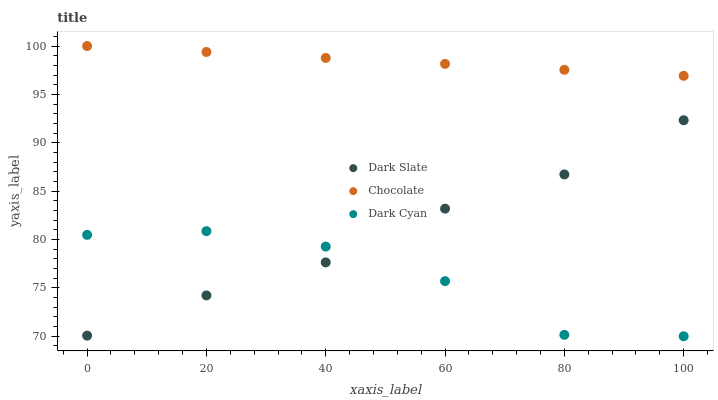Does Dark Cyan have the minimum area under the curve?
Answer yes or no. Yes. Does Chocolate have the maximum area under the curve?
Answer yes or no. Yes. Does Dark Slate have the minimum area under the curve?
Answer yes or no. No. Does Dark Slate have the maximum area under the curve?
Answer yes or no. No. Is Chocolate the smoothest?
Answer yes or no. Yes. Is Dark Cyan the roughest?
Answer yes or no. Yes. Is Dark Slate the smoothest?
Answer yes or no. No. Is Dark Slate the roughest?
Answer yes or no. No. Does Dark Cyan have the lowest value?
Answer yes or no. Yes. Does Dark Slate have the lowest value?
Answer yes or no. No. Does Chocolate have the highest value?
Answer yes or no. Yes. Does Dark Slate have the highest value?
Answer yes or no. No. Is Dark Cyan less than Chocolate?
Answer yes or no. Yes. Is Chocolate greater than Dark Slate?
Answer yes or no. Yes. Does Dark Slate intersect Dark Cyan?
Answer yes or no. Yes. Is Dark Slate less than Dark Cyan?
Answer yes or no. No. Is Dark Slate greater than Dark Cyan?
Answer yes or no. No. Does Dark Cyan intersect Chocolate?
Answer yes or no. No. 